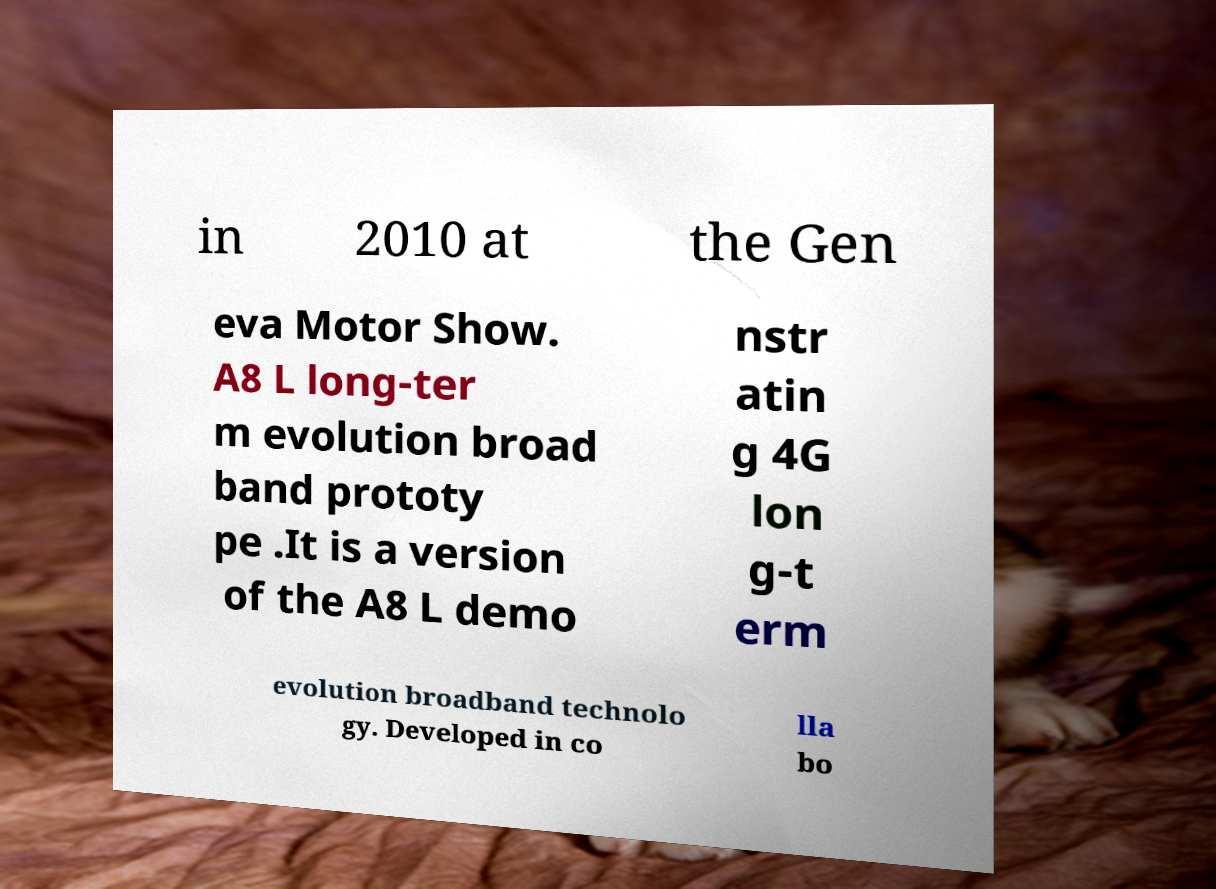Please identify and transcribe the text found in this image. in 2010 at the Gen eva Motor Show. A8 L long-ter m evolution broad band prototy pe .It is a version of the A8 L demo nstr atin g 4G lon g-t erm evolution broadband technolo gy. Developed in co lla bo 